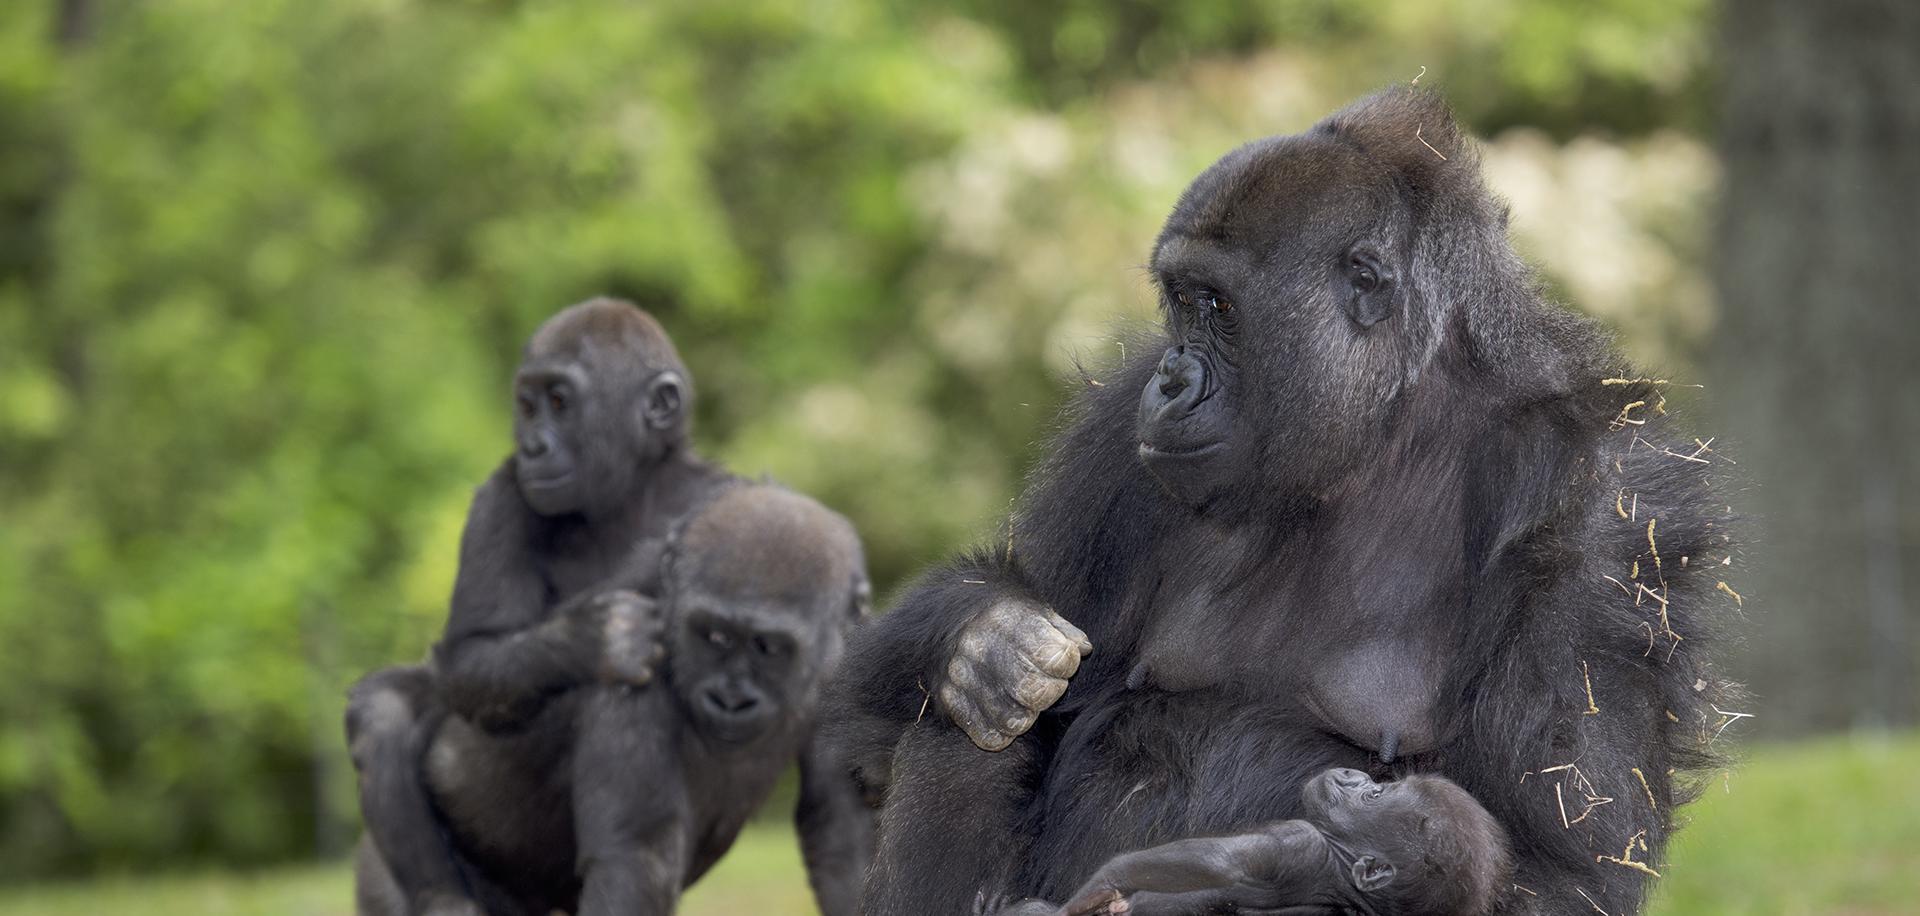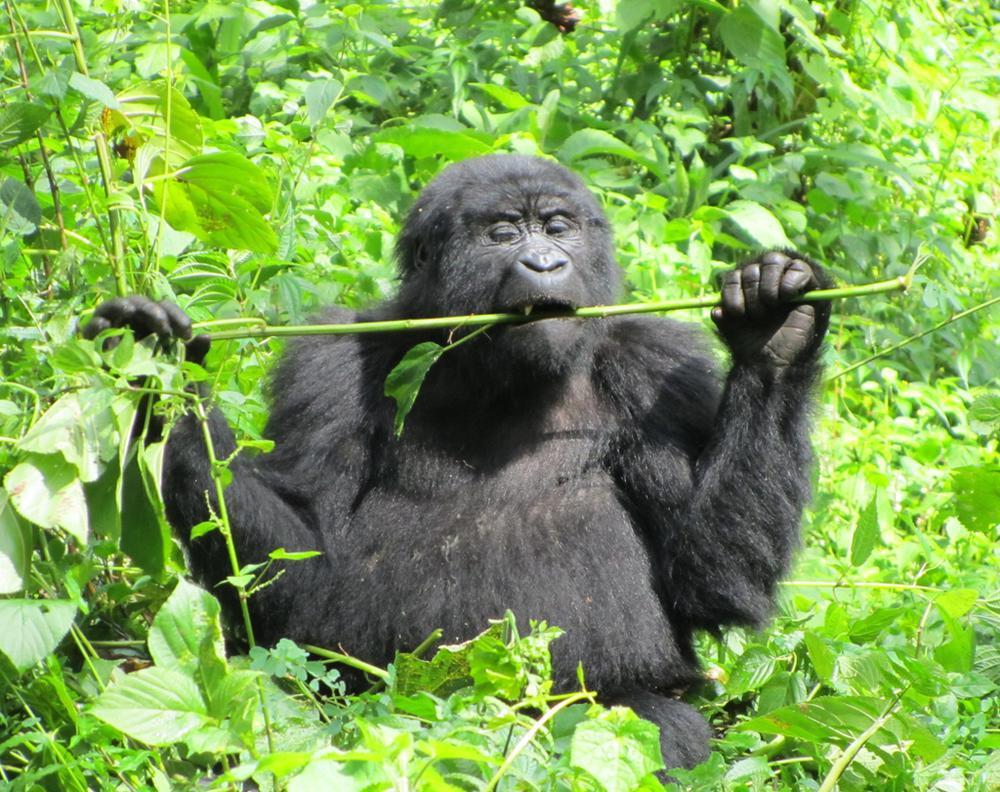The first image is the image on the left, the second image is the image on the right. Given the left and right images, does the statement "The left image shows a lone gorilla munching foliage, and the right image shows at least one adult gorilla with a baby gorilla." hold true? Answer yes or no. No. The first image is the image on the left, the second image is the image on the right. Assess this claim about the two images: "There are at least two gorillas in the right image.". Correct or not? Answer yes or no. No. 